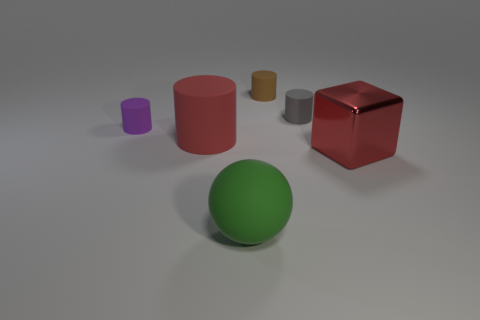Imagine these objects are part of a toy set. What kind of game could children play with them? These objects could be used in a sorting game where children categorize them by shape or color. Additionally, they could be used in a building game where kids stack the objects to create different structures, enhancing their motor skills and creativity. 